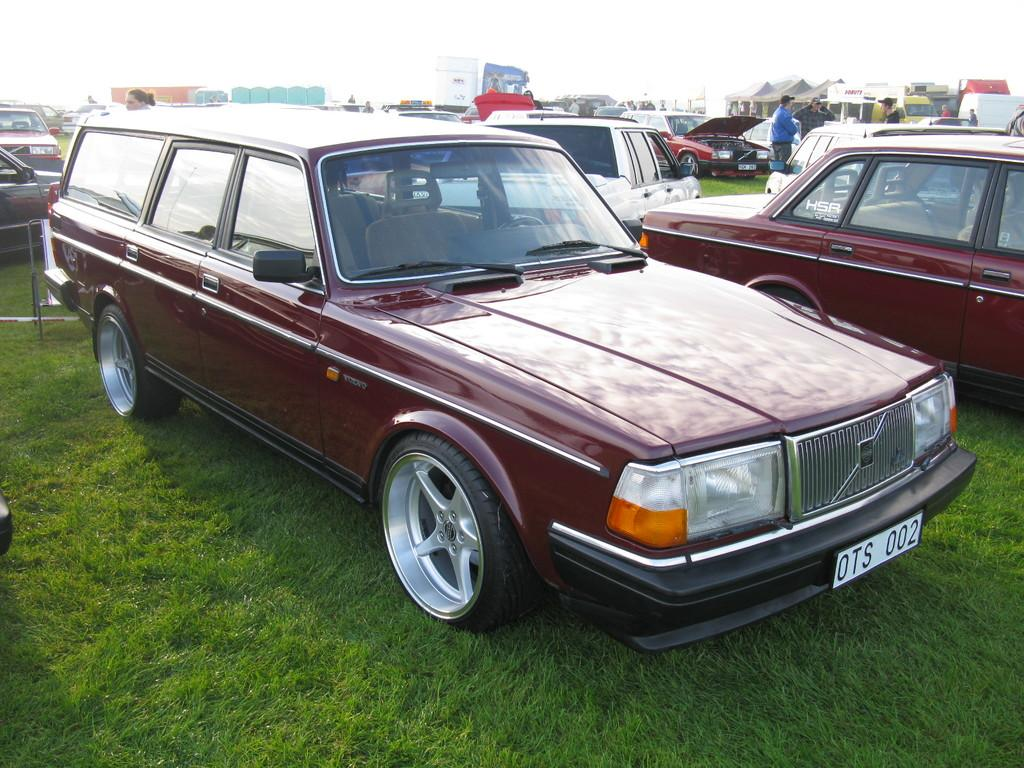What is the main subject of the image? The main subject of the image is many cars. What can be seen on the ground in the image? There is grass on the ground in the image. What is happening in the background of the image? There are people standing, tents, and posters in the background of the image. Where is the shelf located in the image? There is no shelf present in the image. What is the son doing in the image? There is no son present in the image. 